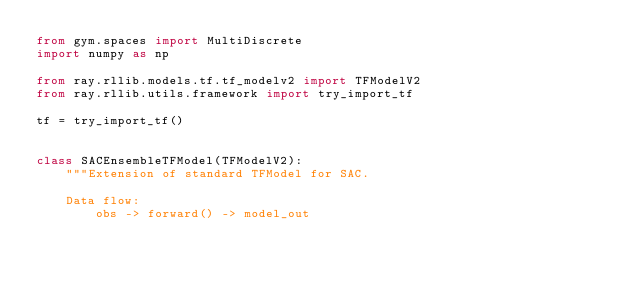Convert code to text. <code><loc_0><loc_0><loc_500><loc_500><_Python_>from gym.spaces import MultiDiscrete
import numpy as np

from ray.rllib.models.tf.tf_modelv2 import TFModelV2
from ray.rllib.utils.framework import try_import_tf

tf = try_import_tf()


class SACEnsembleTFModel(TFModelV2):
    """Extension of standard TFModel for SAC.

    Data flow:
        obs -> forward() -> model_out</code> 